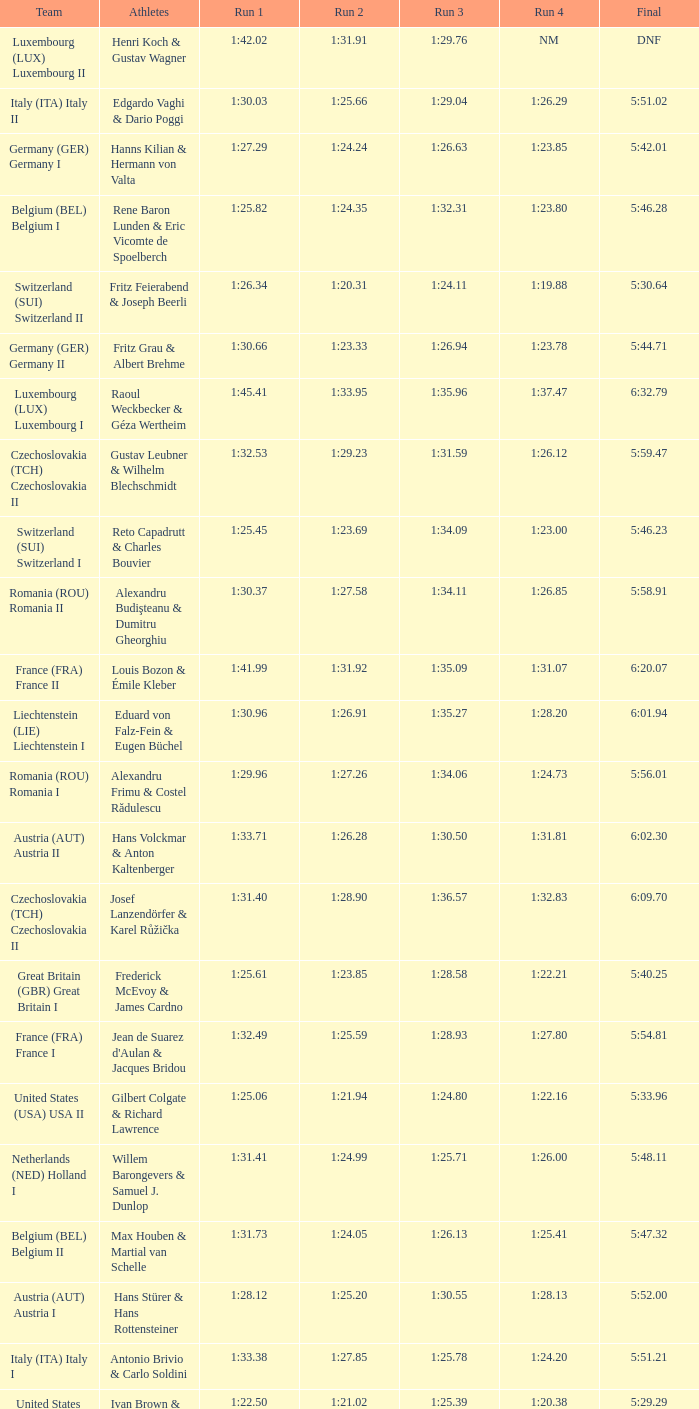Which Run 4 has Athletes of alexandru frimu & costel rădulescu? 1:24.73. 